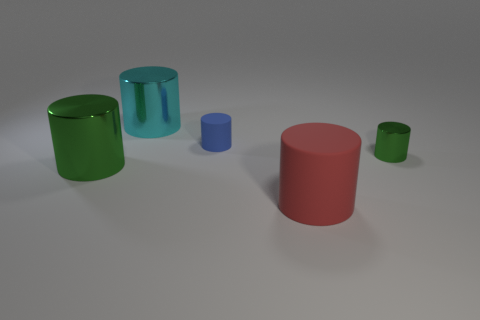Are there any other things that are the same color as the small metal thing?
Offer a terse response. Yes. Are there the same number of cylinders that are right of the tiny matte object and tiny green objects that are behind the small green cylinder?
Make the answer very short. No. There is a red object; is it the same size as the green cylinder that is right of the large green cylinder?
Your response must be concise. No. Is there a big red rubber thing behind the shiny cylinder that is on the right side of the big cyan shiny object?
Provide a succinct answer. No. Are there any tiny rubber things that have the same shape as the small green metallic thing?
Your response must be concise. Yes. What number of tiny things are behind the matte cylinder behind the large thing that is left of the large cyan thing?
Offer a terse response. 0. Does the small metal cylinder have the same color as the big metallic thing in front of the tiny green shiny object?
Provide a short and direct response. Yes. What number of things are either green cylinders that are left of the blue matte cylinder or big objects that are in front of the tiny matte cylinder?
Make the answer very short. 2. Are there more rubber objects on the left side of the big red rubber cylinder than large metal objects that are right of the blue matte cylinder?
Give a very brief answer. Yes. There is a big thing that is to the left of the big metallic thing behind the green shiny cylinder that is on the right side of the big cyan object; what is it made of?
Your response must be concise. Metal. 